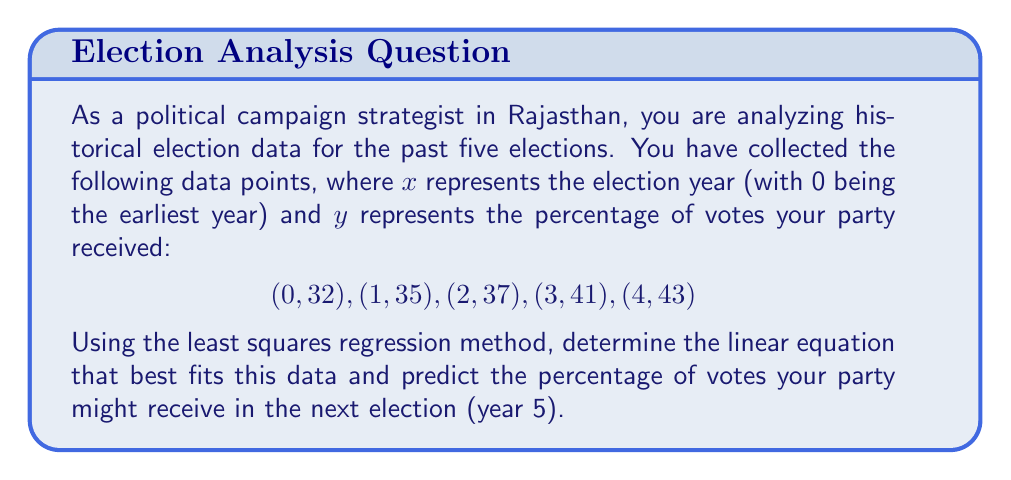Solve this math problem. To find the least squares regression line, we'll use the formula:

$y = mx + b$

Where $m$ is the slope and $b$ is the y-intercept.

Step 1: Calculate the means of $x$ and $y$.
$\bar{x} = \frac{0 + 1 + 2 + 3 + 4}{5} = 2$
$\bar{y} = \frac{32 + 35 + 37 + 41 + 43}{5} = 37.6$

Step 2: Calculate $\sum(x - \bar{x})(y - \bar{y})$ and $\sum(x - \bar{x})^2$.
$\sum(x - \bar{x})(y - \bar{y}) = (-2)(-5.6) + (-1)(-2.6) + (0)(-0.6) + (1)(3.4) + (2)(5.4) = 28$
$\sum(x - \bar{x})^2 = (-2)^2 + (-1)^2 + 0^2 + 1^2 + 2^2 = 10$

Step 3: Calculate the slope $m$.
$m = \frac{\sum(x - \bar{x})(y - \bar{y})}{\sum(x - \bar{x})^2} = \frac{28}{10} = 2.8$

Step 4: Calculate the y-intercept $b$.
$b = \bar{y} - m\bar{x} = 37.6 - 2.8(2) = 32$

Step 5: Write the equation of the least squares regression line.
$y = 2.8x + 32$

Step 6: Predict the percentage of votes for the next election (year 5).
$y = 2.8(5) + 32 = 46$

Therefore, the predicted percentage of votes for year 5 is 46%.
Answer: $y = 2.8x + 32$; 46% 